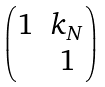Convert formula to latex. <formula><loc_0><loc_0><loc_500><loc_500>\begin{pmatrix} 1 & k _ { N } \\ & 1 \end{pmatrix}</formula> 